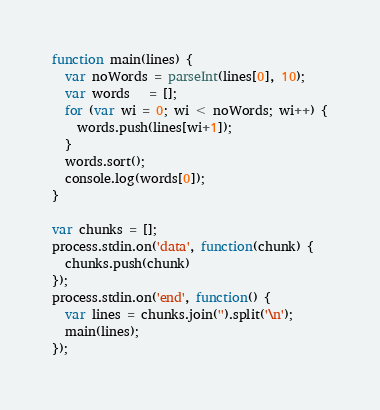Convert code to text. <code><loc_0><loc_0><loc_500><loc_500><_JavaScript_>function main(lines) {
  var noWords = parseInt(lines[0], 10);
  var words   = [];
  for (var wi = 0; wi < noWords; wi++) {
    words.push(lines[wi+1]);
  }
  words.sort();
  console.log(words[0]);
}

var chunks = [];
process.stdin.on('data', function(chunk) {
  chunks.push(chunk)
});
process.stdin.on('end', function() {
  var lines = chunks.join('').split('\n');
  main(lines);
});</code> 